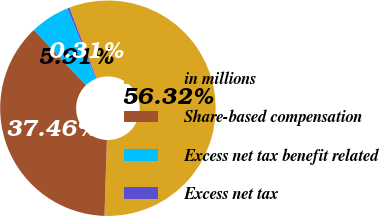Convert chart. <chart><loc_0><loc_0><loc_500><loc_500><pie_chart><fcel>in millions<fcel>Share-based compensation<fcel>Excess net tax benefit related<fcel>Excess net tax<nl><fcel>56.33%<fcel>37.46%<fcel>5.91%<fcel>0.31%<nl></chart> 